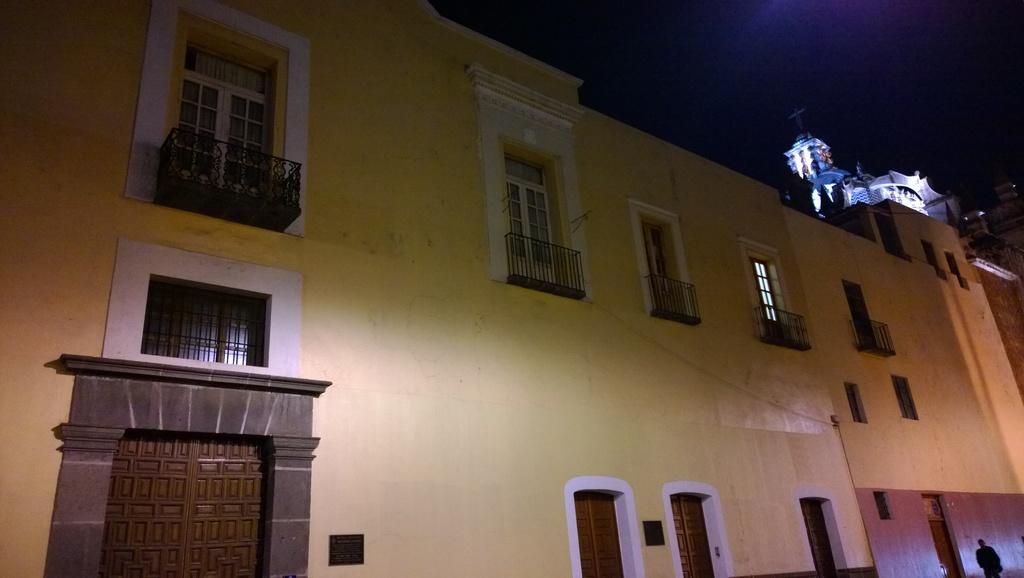In one or two sentences, can you explain what this image depicts? In this picture we can see few buildings, lights and metal rods, at the right bottom of the image we can see a person. 